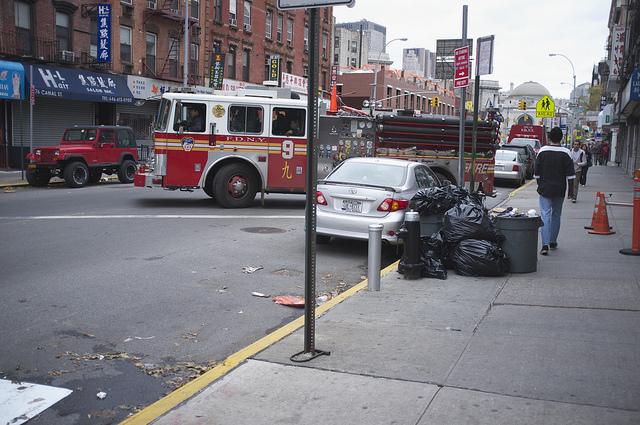Where is the number 10?
Be succinct. Fire truck. Is this an urban or rural setting?
Write a very short answer. Urban. What's the name on the truck?
Short answer required. Fdny. Is it trash day?
Concise answer only. Yes. What number is on the fire truck?
Short answer required. 9. 